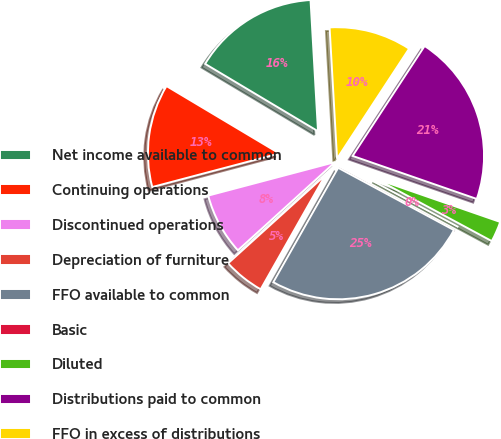<chart> <loc_0><loc_0><loc_500><loc_500><pie_chart><fcel>Net income available to common<fcel>Continuing operations<fcel>Discontinued operations<fcel>Depreciation of furniture<fcel>FFO available to common<fcel>Basic<fcel>Diluted<fcel>Distributions paid to common<fcel>FFO in excess of distributions<nl><fcel>15.53%<fcel>12.68%<fcel>7.61%<fcel>5.07%<fcel>25.36%<fcel>0.0%<fcel>2.54%<fcel>21.08%<fcel>10.14%<nl></chart> 